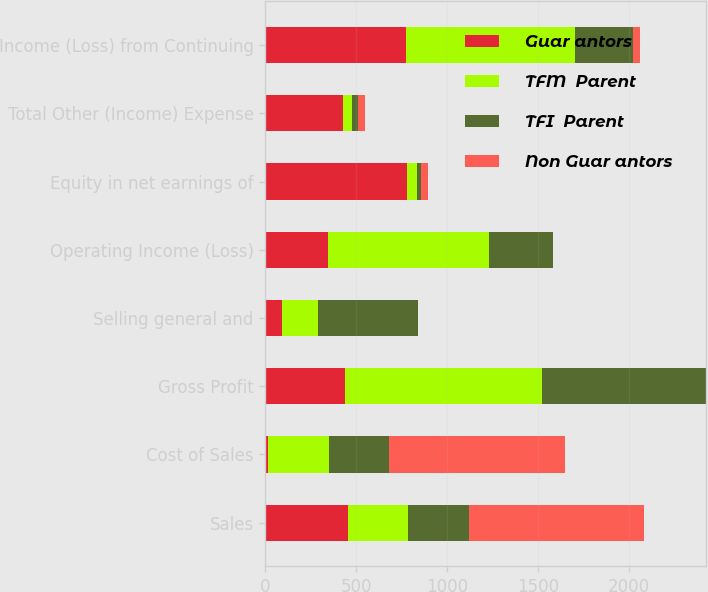<chart> <loc_0><loc_0><loc_500><loc_500><stacked_bar_chart><ecel><fcel>Sales<fcel>Cost of Sales<fcel>Gross Profit<fcel>Selling general and<fcel>Operating Income (Loss)<fcel>Equity in net earnings of<fcel>Total Other (Income) Expense<fcel>Income (Loss) from Continuing<nl><fcel>Guar antors<fcel>454<fcel>16<fcel>438<fcel>93<fcel>345<fcel>782<fcel>429<fcel>774<nl><fcel>TFM  Parent<fcel>332.5<fcel>332.5<fcel>1083<fcel>199<fcel>884<fcel>51<fcel>48<fcel>932<nl><fcel>TFI  Parent<fcel>332.5<fcel>332.5<fcel>905<fcel>550<fcel>355<fcel>25<fcel>35<fcel>320<nl><fcel>Non Guar antors<fcel>966<fcel>966<fcel>0<fcel>0<fcel>0<fcel>37<fcel>37<fcel>37<nl></chart> 